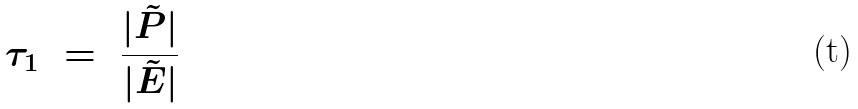<formula> <loc_0><loc_0><loc_500><loc_500>\tau _ { 1 } \ = \ \frac { | \tilde { P } | } { | \tilde { E } | }</formula> 